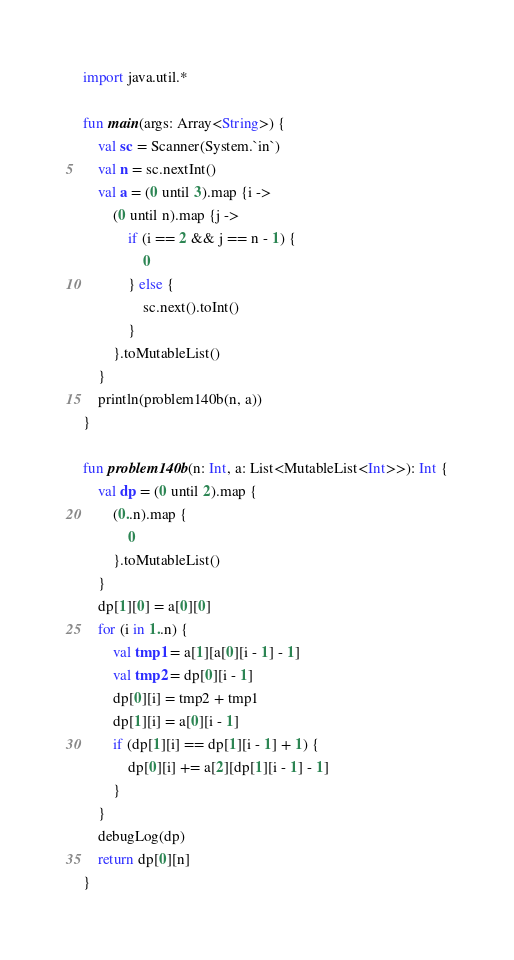<code> <loc_0><loc_0><loc_500><loc_500><_Kotlin_>import java.util.*

fun main(args: Array<String>) {
    val sc = Scanner(System.`in`)
    val n = sc.nextInt()
    val a = (0 until 3).map {i ->
        (0 until n).map {j ->
            if (i == 2 && j == n - 1) {
                0
            } else {
                sc.next().toInt()
            }
        }.toMutableList()
    }
    println(problem140b(n, a))
}

fun problem140b(n: Int, a: List<MutableList<Int>>): Int {
    val dp = (0 until 2).map {
        (0..n).map {
            0
        }.toMutableList()
    }
    dp[1][0] = a[0][0]
    for (i in 1..n) {
        val tmp1 = a[1][a[0][i - 1] - 1]
        val tmp2 = dp[0][i - 1]
        dp[0][i] = tmp2 + tmp1
        dp[1][i] = a[0][i - 1]
        if (dp[1][i] == dp[1][i - 1] + 1) {
            dp[0][i] += a[2][dp[1][i - 1] - 1]
        }
    }
    debugLog(dp)
    return dp[0][n]
}</code> 